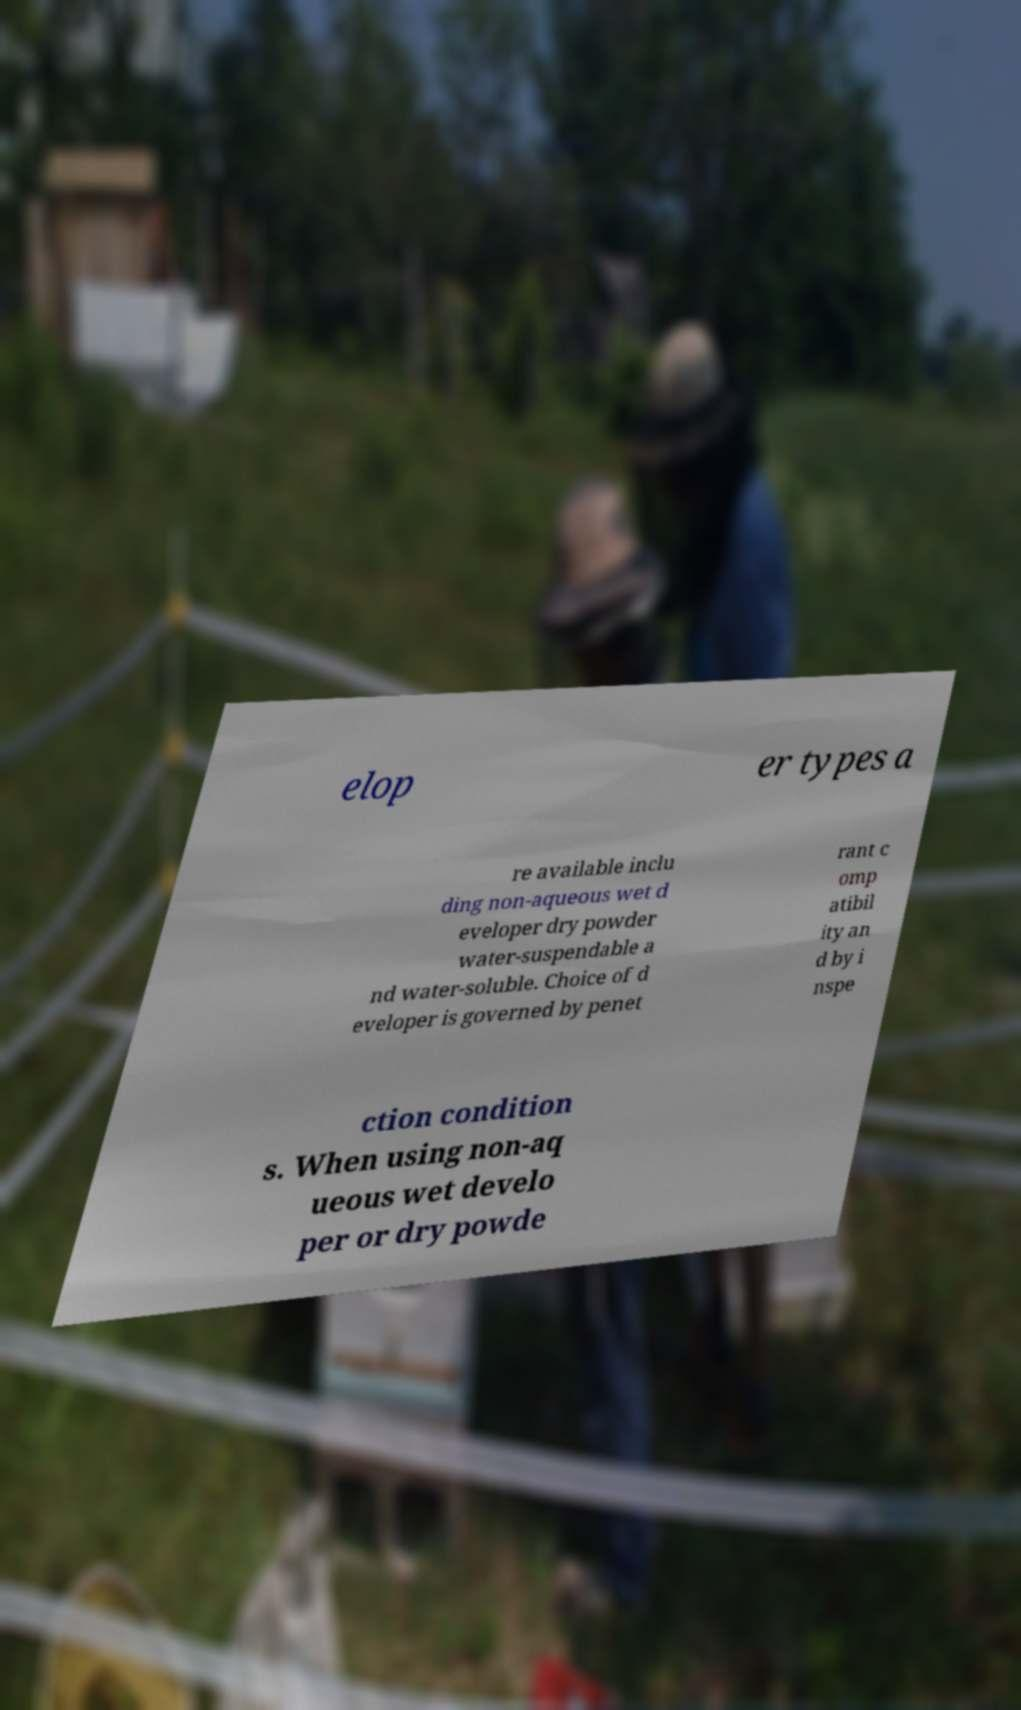Can you accurately transcribe the text from the provided image for me? elop er types a re available inclu ding non-aqueous wet d eveloper dry powder water-suspendable a nd water-soluble. Choice of d eveloper is governed by penet rant c omp atibil ity an d by i nspe ction condition s. When using non-aq ueous wet develo per or dry powde 